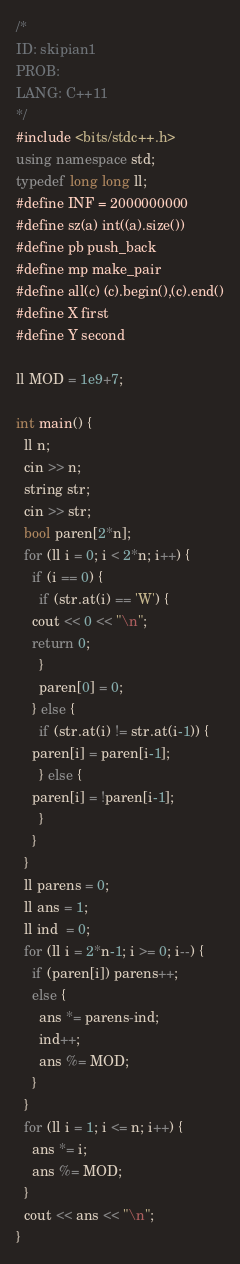<code> <loc_0><loc_0><loc_500><loc_500><_C++_>/*
ID: skipian1
PROB: 
LANG: C++11
*/
#include <bits/stdc++.h>
using namespace std;
typedef long long ll;
#define INF = 2000000000
#define sz(a) int((a).size())
#define pb push_back
#define mp make_pair
#define all(c) (c).begin(),(c).end()
#define X first
#define Y second

ll MOD = 1e9+7;

int main() {
  ll n;
  cin >> n;
  string str;
  cin >> str;
  bool paren[2*n];
  for (ll i = 0; i < 2*n; i++) {
    if (i == 0) {
      if (str.at(i) == 'W') {
	cout << 0 << "\n";
	return 0;
      }
      paren[0] = 0;
    } else {
      if (str.at(i) != str.at(i-1)) {
	paren[i] = paren[i-1];
      } else {
	paren[i] = !paren[i-1];
      }
    }
  }
  ll parens = 0;
  ll ans = 1;
  ll ind  = 0;
  for (ll i = 2*n-1; i >= 0; i--) {
    if (paren[i]) parens++;
    else {
      ans *= parens-ind;
      ind++;
      ans %= MOD;
    }
  }
  for (ll i = 1; i <= n; i++) {
    ans *= i;
    ans %= MOD;
  }
  cout << ans << "\n";
}
</code> 